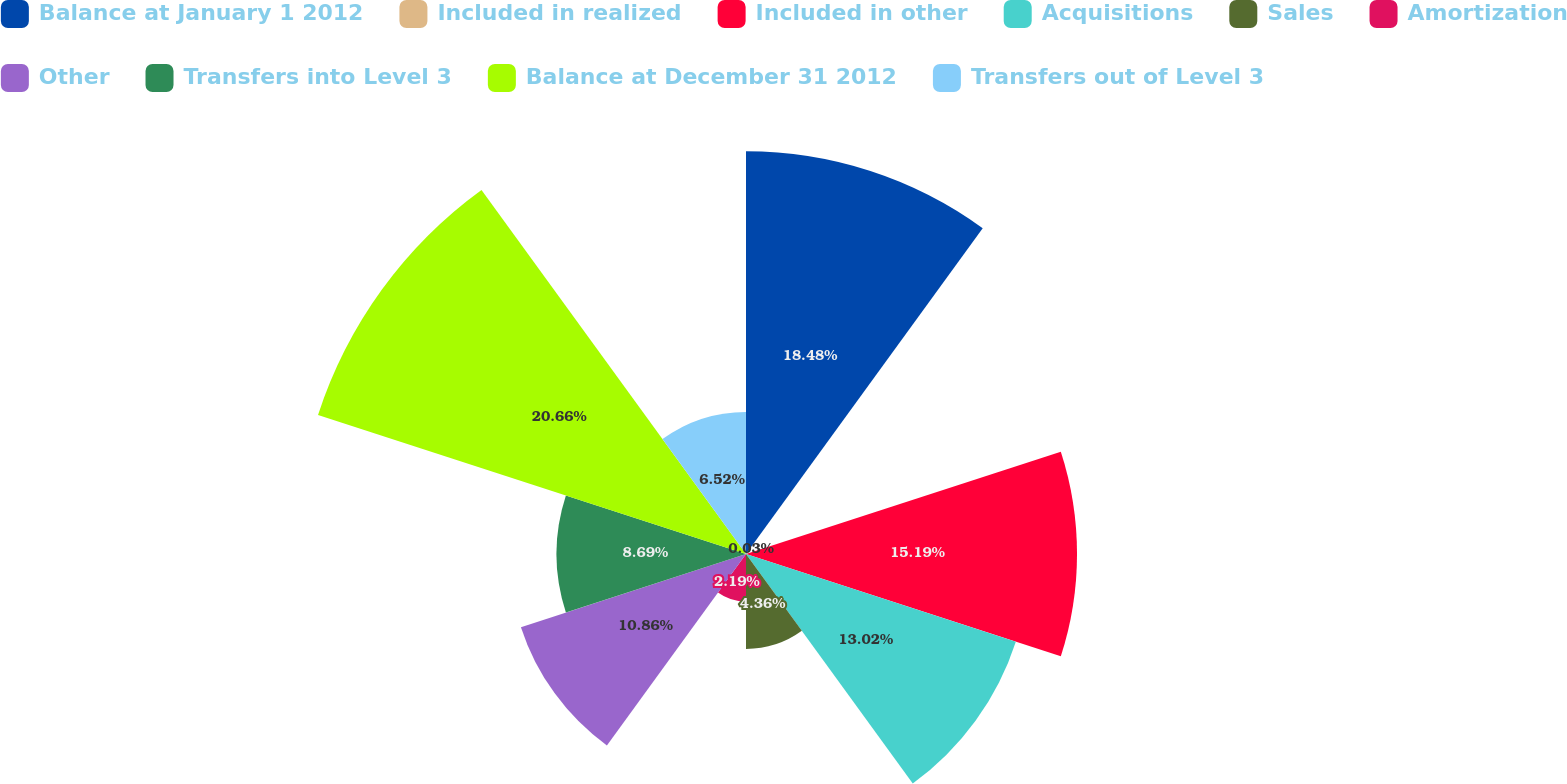Convert chart. <chart><loc_0><loc_0><loc_500><loc_500><pie_chart><fcel>Balance at January 1 2012<fcel>Included in realized<fcel>Included in other<fcel>Acquisitions<fcel>Sales<fcel>Amortization<fcel>Other<fcel>Transfers into Level 3<fcel>Balance at December 31 2012<fcel>Transfers out of Level 3<nl><fcel>18.48%<fcel>0.03%<fcel>15.19%<fcel>13.02%<fcel>4.36%<fcel>2.19%<fcel>10.86%<fcel>8.69%<fcel>20.65%<fcel>6.52%<nl></chart> 